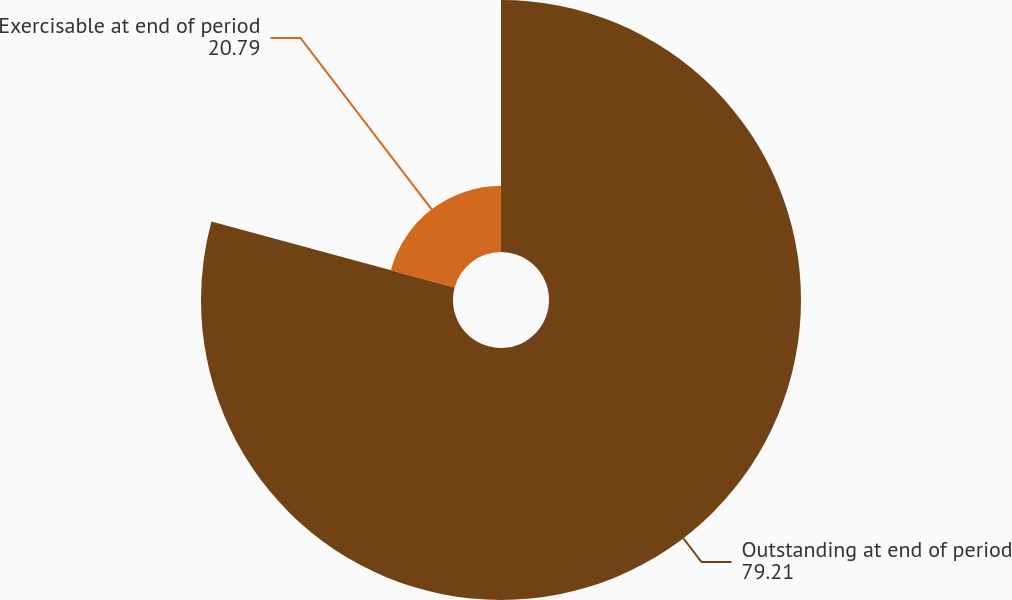Convert chart to OTSL. <chart><loc_0><loc_0><loc_500><loc_500><pie_chart><fcel>Outstanding at end of period<fcel>Exercisable at end of period<nl><fcel>79.21%<fcel>20.79%<nl></chart> 